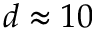Convert formula to latex. <formula><loc_0><loc_0><loc_500><loc_500>d \approx 1 0</formula> 